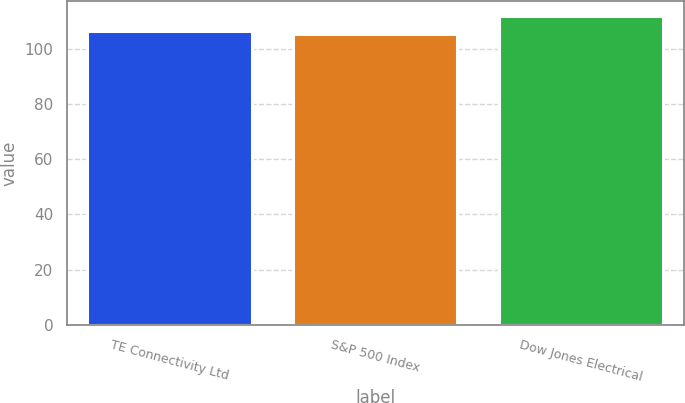Convert chart. <chart><loc_0><loc_0><loc_500><loc_500><bar_chart><fcel>TE Connectivity Ltd<fcel>S&P 500 Index<fcel>Dow Jones Electrical<nl><fcel>106.38<fcel>105.37<fcel>111.66<nl></chart> 